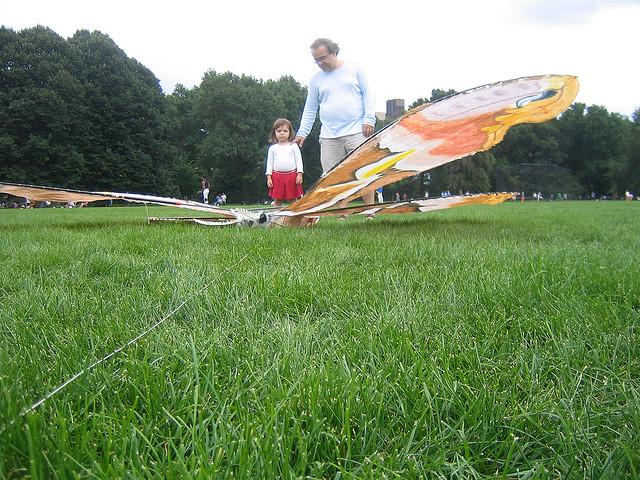What color is the grass?
Write a very short answer. Green. What color is the child's shorts?
Give a very brief answer. Red. Is this photo indoors?
Answer briefly. No. 